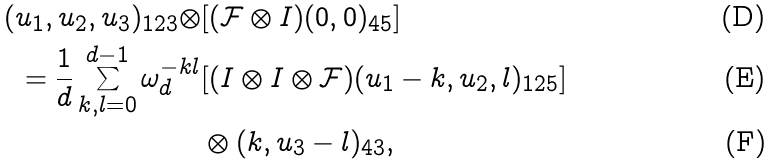<formula> <loc_0><loc_0><loc_500><loc_500>( u _ { 1 } , u _ { 2 } , u _ { 3 } ) _ { 1 2 3 } \otimes & [ ( \mathcal { F } \otimes I ) ( 0 , 0 ) _ { 4 5 } ] \\ = { \frac { 1 } { d } } \sum _ { k , l = 0 } ^ { d - 1 } \omega _ { d } ^ { - k l } & [ ( I \otimes I \otimes \mathcal { F } ) ( u _ { 1 } - k , u _ { 2 } , l ) _ { 1 2 5 } ] \\ & \otimes ( k , u _ { 3 } - l ) _ { 4 3 } ,</formula> 